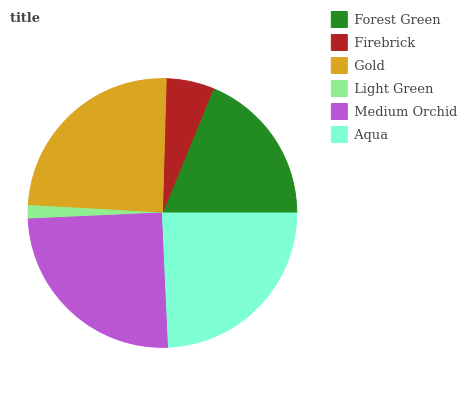Is Light Green the minimum?
Answer yes or no. Yes. Is Medium Orchid the maximum?
Answer yes or no. Yes. Is Firebrick the minimum?
Answer yes or no. No. Is Firebrick the maximum?
Answer yes or no. No. Is Forest Green greater than Firebrick?
Answer yes or no. Yes. Is Firebrick less than Forest Green?
Answer yes or no. Yes. Is Firebrick greater than Forest Green?
Answer yes or no. No. Is Forest Green less than Firebrick?
Answer yes or no. No. Is Aqua the high median?
Answer yes or no. Yes. Is Forest Green the low median?
Answer yes or no. Yes. Is Medium Orchid the high median?
Answer yes or no. No. Is Firebrick the low median?
Answer yes or no. No. 